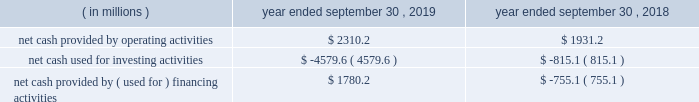Credit facilities .
As such , our foreign cash and cash equivalents are not expected to be a key source of liquidity to our domestic operations .
At september 30 , 2019 , we had approximately $ 2.9 billion of availability under our committed credit facilities , primarily under our revolving credit facility , the majority of which matures on july 1 , 2022 .
This liquidity may be used to provide for ongoing working capital needs and for other general corporate purposes , including acquisitions , dividends and stock repurchases .
Certain restrictive covenants govern our maximum availability under the credit facilities .
We test and report our compliance with these covenants as required and we were in compliance with all of these covenants at september 30 , 2019 .
At september 30 , 2019 , we had $ 129.8 million of outstanding letters of credit not drawn cash and cash equivalents were $ 151.6 million at september 30 , 2019 and $ 636.8 million at september 30 , 2018 .
We used a significant portion of the cash and cash equivalents on hand at september 30 , 2018 in connection with the closing of the kapstone acquisition .
Primarily all of the cash and cash equivalents at september 30 , 2019 were held outside of the u.s .
At september 30 , 2019 , total debt was $ 10063.4 million , $ 561.1 million of which was current .
At september 30 , 2018 , total debt was $ 6415.2 million , $ 740.7 million of which was current .
The increase in debt was primarily related to the kapstone acquisition .
Cash flow activity .
Net cash provided by operating activities during fiscal 2019 increased $ 379.0 million from fiscal 2018 primarily due to higher cash earnings and a $ 340.3 million net decrease in the use of working capital compared to the prior year .
As a result of the retrospective adoption of asu 2016-15 and asu 2016-18 ( each as hereinafter defined ) as discussed in 201cnote 1 .
Description of business and summary of significant accounting policies 201d of the notes to consolidated financial statements , net cash provided by operating activities for fiscal 2018 was reduced by $ 489.7 million and cash provided by investing activities increased $ 483.8 million , primarily for the change in classification of proceeds received for beneficial interests obtained for transferring trade receivables in securitization transactions .
Net cash used for investing activities of $ 4579.6 million in fiscal 2019 consisted primarily of $ 3374.2 million for cash paid for the purchase of businesses , net of cash acquired ( excluding the assumption of debt ) , primarily related to the kapstone acquisition , and $ 1369.1 million for capital expenditures that were partially offset by $ 119.1 million of proceeds from the sale of property , plant and equipment primarily related to the sale of our atlanta beverage facility , $ 33.2 million of proceeds from corporate owned life insurance benefits and $ 25.5 million of proceeds from property , plant and equipment insurance proceeds related to the panama city , fl mill .
Net cash used for investing activities of $ 815.1 million in fiscal 2018 consisted primarily of $ 999.9 million for capital expenditures , $ 239.9 million for cash paid for the purchase of businesses , net of cash acquired primarily related to the plymouth acquisition and the schl fcter acquisition , and $ 108.0 million for an investment in grupo gondi .
These investments were partially offset by $ 461.6 million of cash receipts on sold trade receivables as a result of the adoption of asu 2016-15 , $ 24.0 million of proceeds from the sale of certain affiliates as well as our solid waste management brokerage services business and $ 23.3 million of proceeds from the sale of property , plant and equipment .
In fiscal 2019 , net cash provided by financing activities of $ 1780.2 million consisted primarily of a net increase in debt of $ 2314.6 million , primarily related to the kapstone acquisition and partially offset by cash dividends paid to stockholders of $ 467.9 million and purchases of common stock of $ 88.6 million .
In fiscal 2018 , net cash used for financing activities of $ 755.1 million consisted primarily of cash dividends paid to stockholders of $ 440.9 million and purchases of common stock of $ 195.1 million and net repayments of debt of $ 120.1 million. .
What percent did the net cash provided by operations increase between 2018 and 2019? 
Computations: (2310.2 - 1931.2)
Answer: 379.0. 